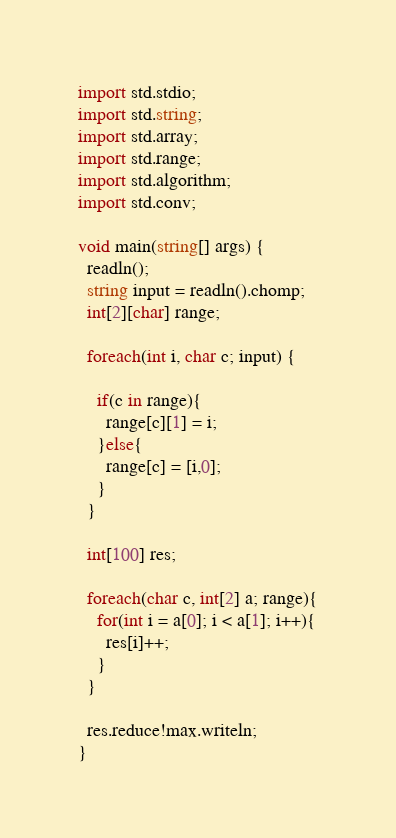Convert code to text. <code><loc_0><loc_0><loc_500><loc_500><_D_>import std.stdio;
import std.string;
import std.array;
import std.range;
import std.algorithm;
import std.conv;

void main(string[] args) {
  readln();
  string input = readln().chomp;
  int[2][char] range;

  foreach(int i, char c; input) {

    if(c in range){
      range[c][1] = i;
    }else{
      range[c] = [i,0];
    }
  }

  int[100] res;

  foreach(char c, int[2] a; range){
    for(int i = a[0]; i < a[1]; i++){
      res[i]++;
    }
  }

  res.reduce!max.writeln;
}</code> 